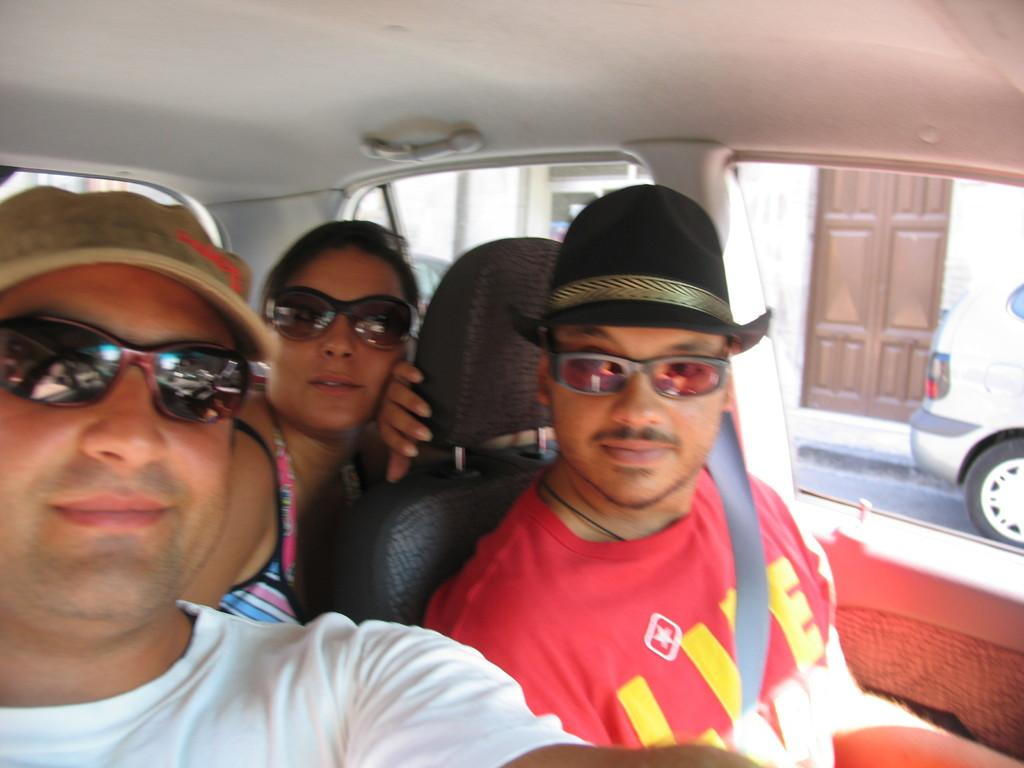How many people are in the car in the image? There are three people seated in the car in the image. What else can be seen in the background of the image? There is a car and a building in the background of the image. What type of ink is being used to write on the carriage in the image? There is no carriage or ink present in the image; it features a car with three people inside and a background with another car and a building. 